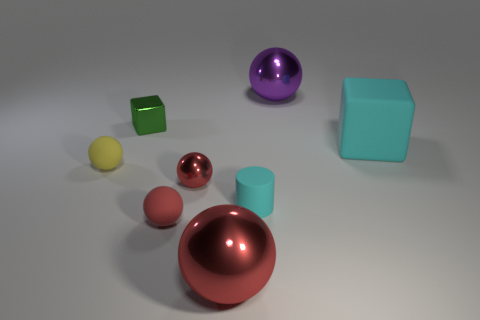There is a purple object that is the same size as the cyan matte cube; what shape is it? sphere 